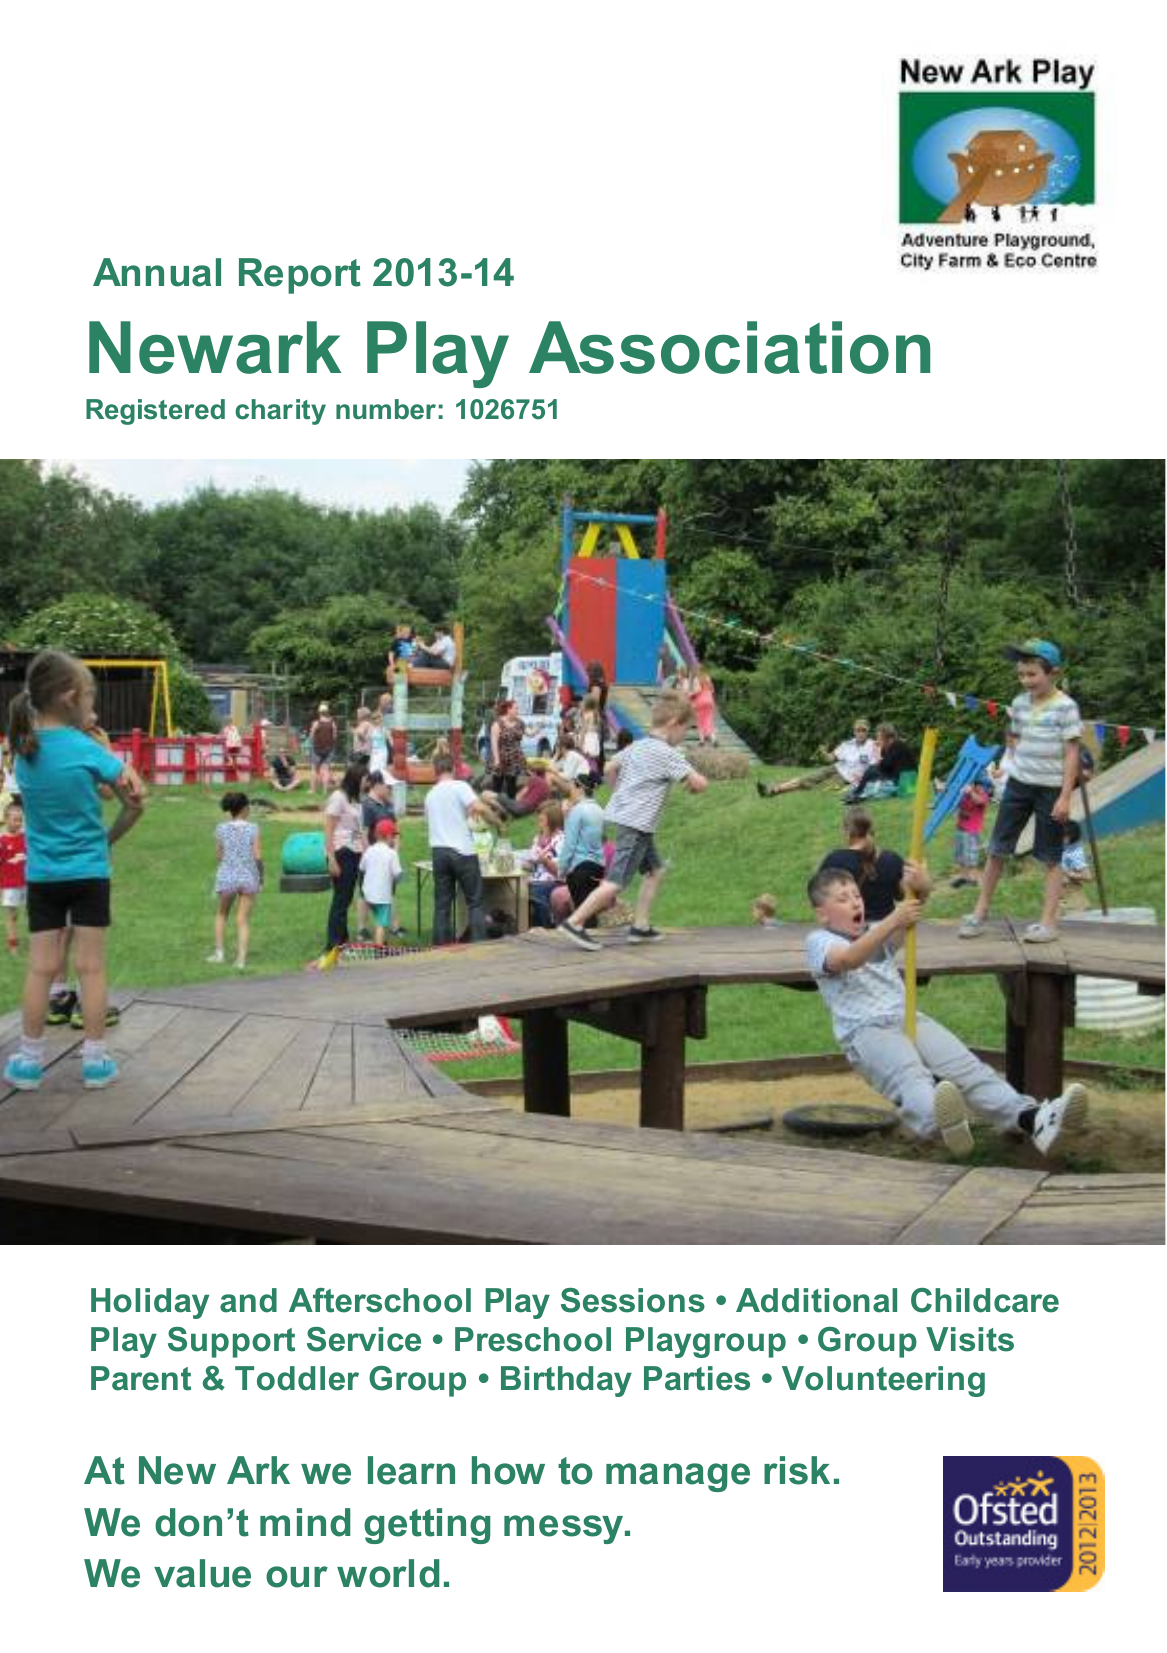What is the value for the address__street_line?
Answer the question using a single word or phrase. 23 HAWTHORN ROAD 